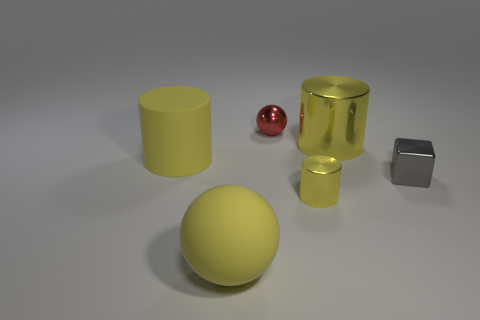Is the tiny yellow thing the same shape as the small red thing?
Your response must be concise. No. There is a shiny object that is on the right side of the large shiny cylinder; what is its size?
Offer a very short reply. Small. There is a metal cube; is it the same size as the yellow metallic thing in front of the large rubber cylinder?
Ensure brevity in your answer.  Yes. Is the number of yellow balls that are behind the gray shiny thing less than the number of brown rubber blocks?
Make the answer very short. No. There is a tiny object that is the same shape as the big metal object; what material is it?
Offer a very short reply. Metal. There is a big thing that is behind the gray object and to the left of the small yellow metal thing; what shape is it?
Provide a short and direct response. Cylinder. There is a tiny gray thing that is the same material as the small yellow cylinder; what shape is it?
Ensure brevity in your answer.  Cube. There is a big yellow cylinder that is to the left of the rubber ball; what material is it?
Offer a terse response. Rubber. There is a cylinder that is left of the yellow ball; is it the same size as the ball that is in front of the gray metallic thing?
Provide a short and direct response. Yes. The large ball has what color?
Your answer should be compact. Yellow. 